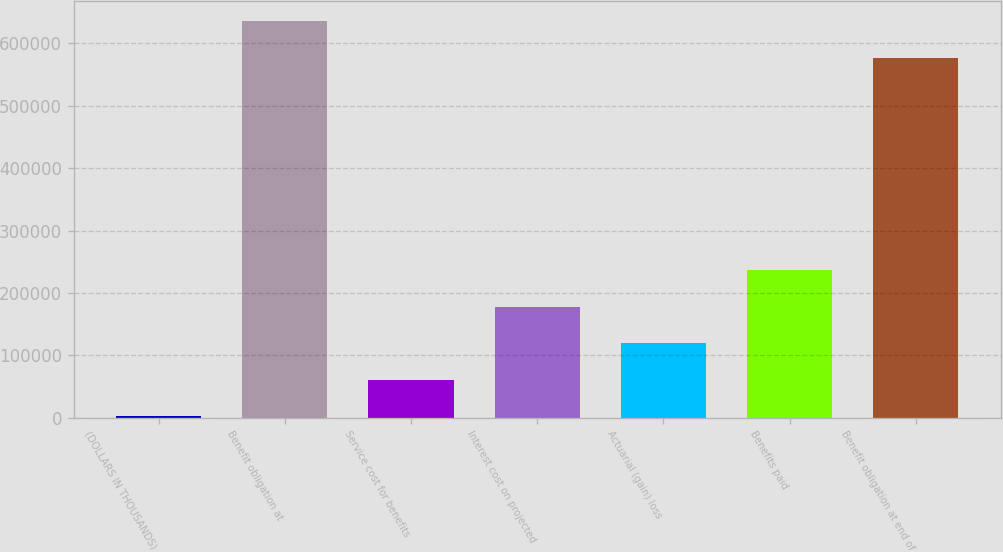Convert chart. <chart><loc_0><loc_0><loc_500><loc_500><bar_chart><fcel>(DOLLARS IN THOUSANDS)<fcel>Benefit obligation at<fcel>Service cost for benefits<fcel>Interest cost on projected<fcel>Actuarial (gain) loss<fcel>Benefits paid<fcel>Benefit obligation at end of<nl><fcel>2016<fcel>635882<fcel>60565.5<fcel>177664<fcel>119115<fcel>236214<fcel>577332<nl></chart> 